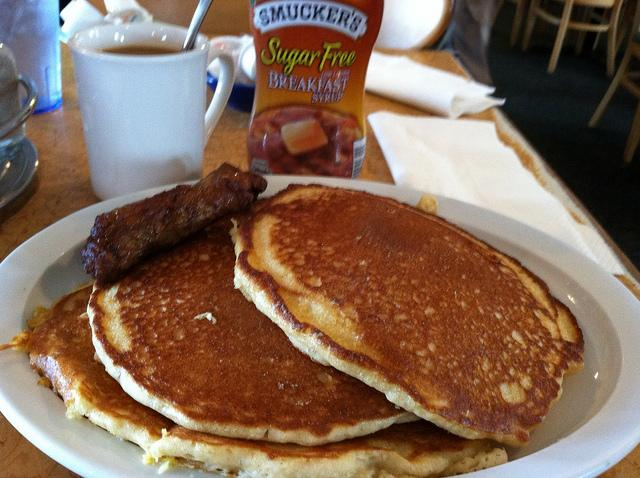What is the Smucker's product replacing? maple syrup 